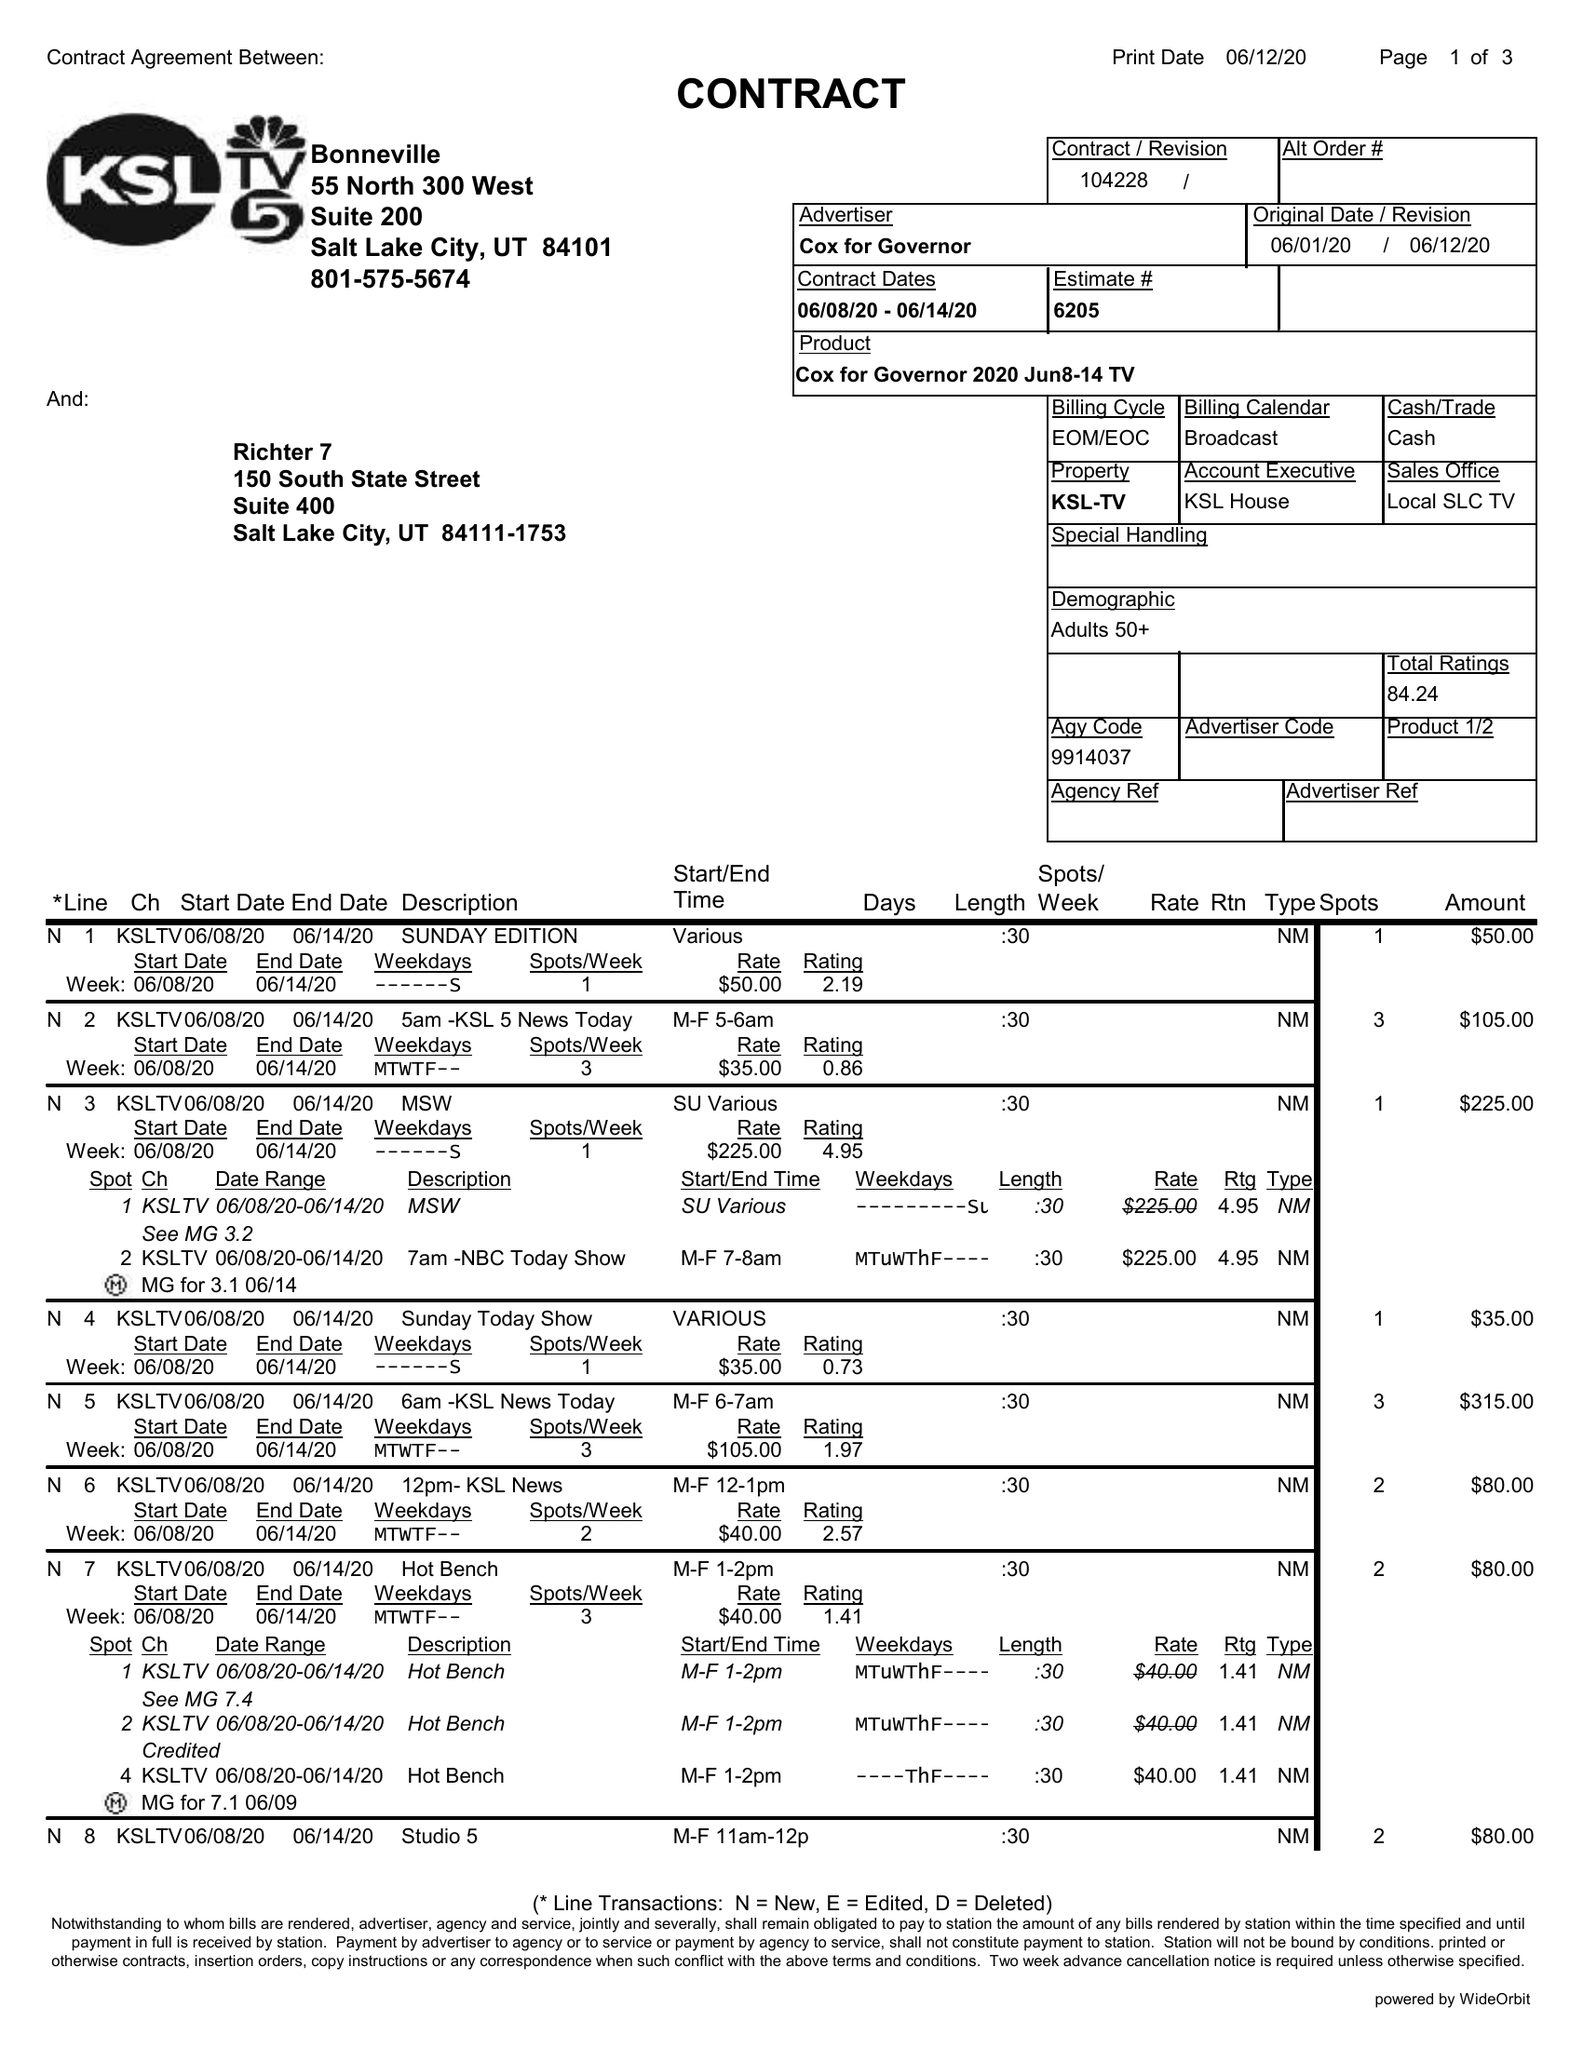What is the value for the contract_num?
Answer the question using a single word or phrase. 104228 